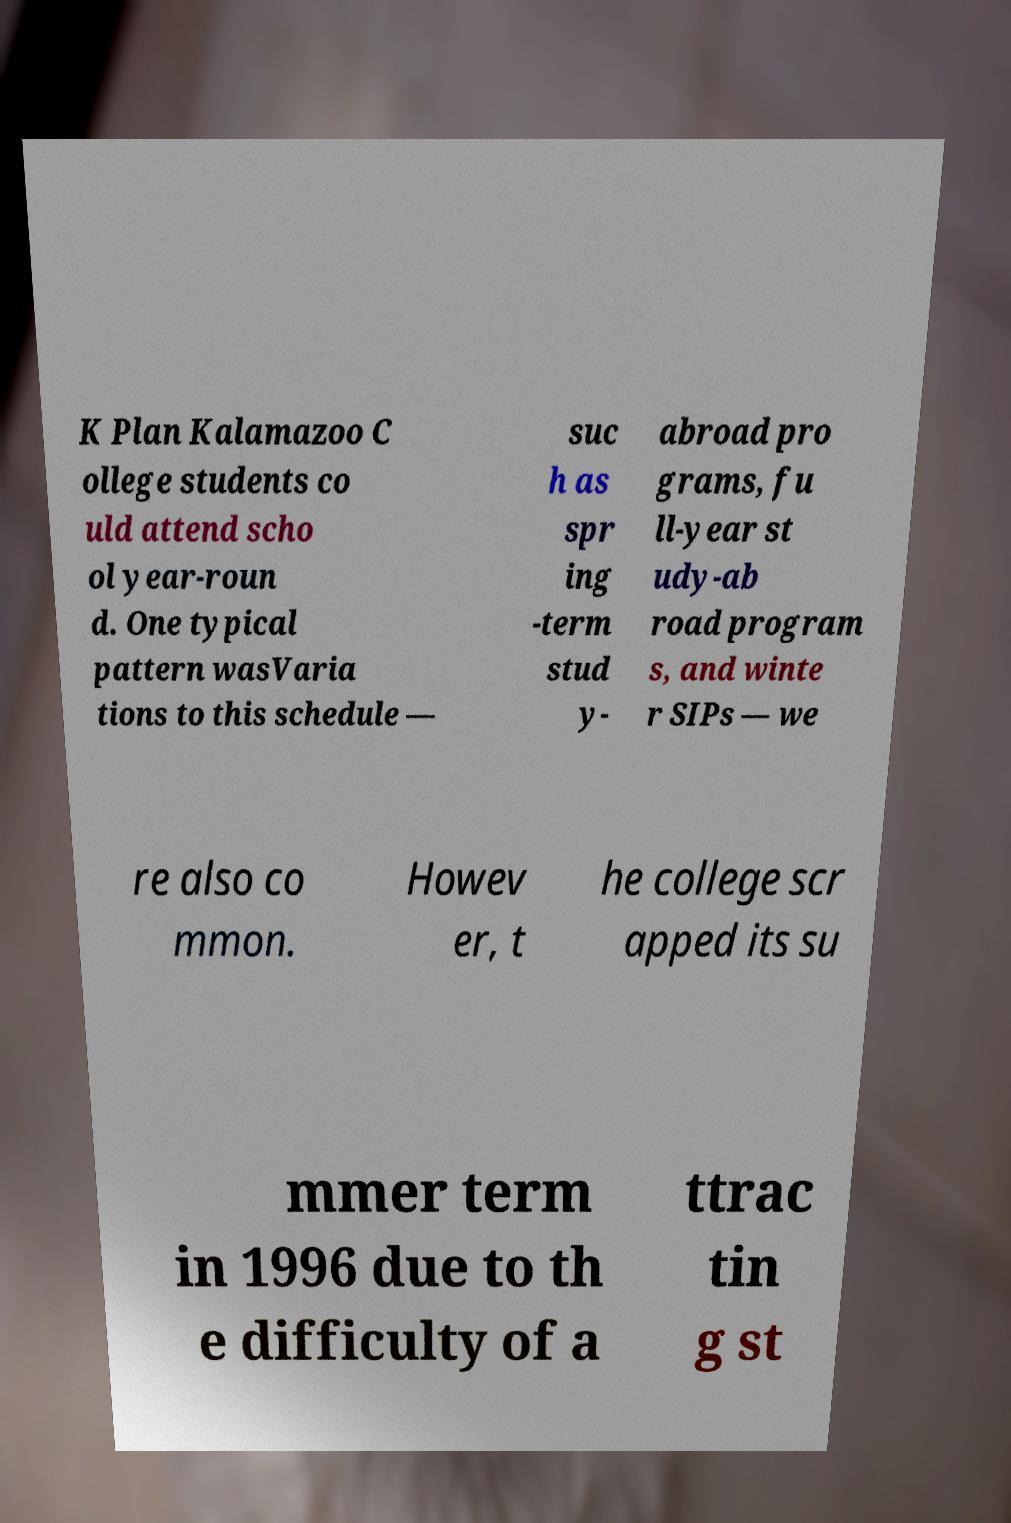Can you read and provide the text displayed in the image?This photo seems to have some interesting text. Can you extract and type it out for me? K Plan Kalamazoo C ollege students co uld attend scho ol year-roun d. One typical pattern wasVaria tions to this schedule — suc h as spr ing -term stud y- abroad pro grams, fu ll-year st udy-ab road program s, and winte r SIPs — we re also co mmon. Howev er, t he college scr apped its su mmer term in 1996 due to th e difficulty of a ttrac tin g st 